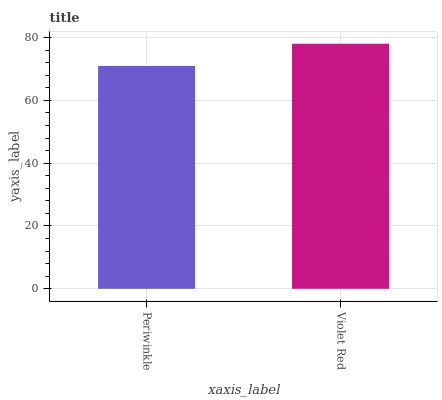Is Periwinkle the minimum?
Answer yes or no. Yes. Is Violet Red the maximum?
Answer yes or no. Yes. Is Violet Red the minimum?
Answer yes or no. No. Is Violet Red greater than Periwinkle?
Answer yes or no. Yes. Is Periwinkle less than Violet Red?
Answer yes or no. Yes. Is Periwinkle greater than Violet Red?
Answer yes or no. No. Is Violet Red less than Periwinkle?
Answer yes or no. No. Is Violet Red the high median?
Answer yes or no. Yes. Is Periwinkle the low median?
Answer yes or no. Yes. Is Periwinkle the high median?
Answer yes or no. No. Is Violet Red the low median?
Answer yes or no. No. 